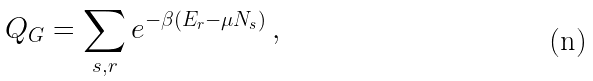<formula> <loc_0><loc_0><loc_500><loc_500>Q _ { G } = \sum _ { s , r } e ^ { - \beta ( E _ { r } - \mu N _ { s } ) } \, ,</formula> 